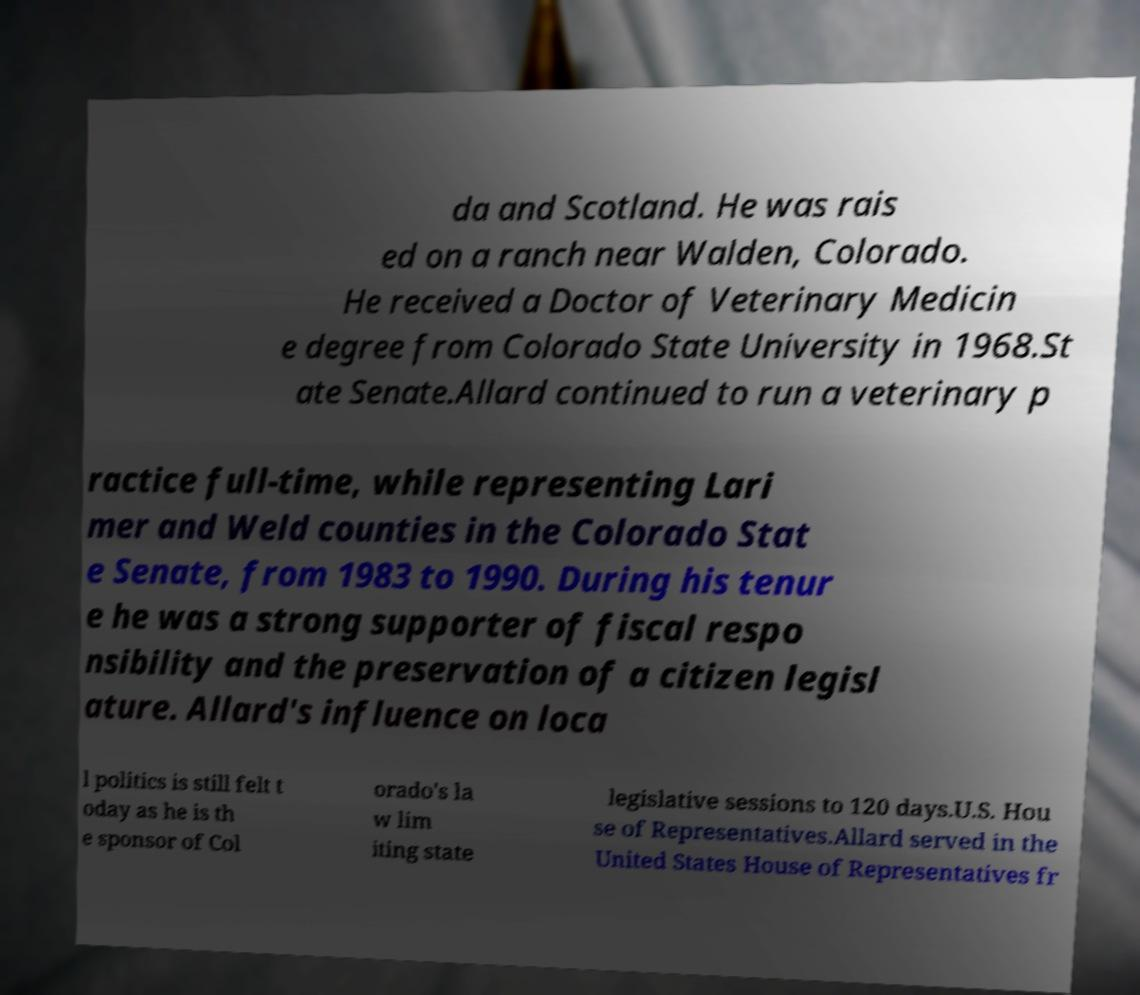Can you read and provide the text displayed in the image?This photo seems to have some interesting text. Can you extract and type it out for me? da and Scotland. He was rais ed on a ranch near Walden, Colorado. He received a Doctor of Veterinary Medicin e degree from Colorado State University in 1968.St ate Senate.Allard continued to run a veterinary p ractice full-time, while representing Lari mer and Weld counties in the Colorado Stat e Senate, from 1983 to 1990. During his tenur e he was a strong supporter of fiscal respo nsibility and the preservation of a citizen legisl ature. Allard's influence on loca l politics is still felt t oday as he is th e sponsor of Col orado's la w lim iting state legislative sessions to 120 days.U.S. Hou se of Representatives.Allard served in the United States House of Representatives fr 